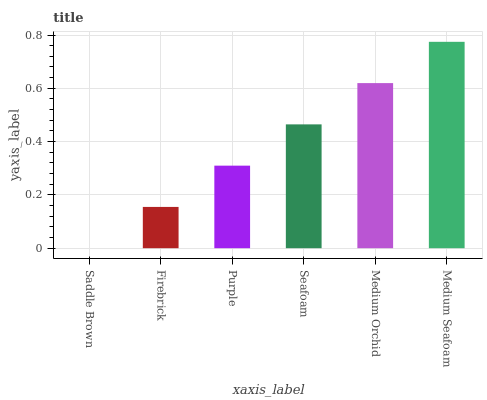Is Saddle Brown the minimum?
Answer yes or no. Yes. Is Medium Seafoam the maximum?
Answer yes or no. Yes. Is Firebrick the minimum?
Answer yes or no. No. Is Firebrick the maximum?
Answer yes or no. No. Is Firebrick greater than Saddle Brown?
Answer yes or no. Yes. Is Saddle Brown less than Firebrick?
Answer yes or no. Yes. Is Saddle Brown greater than Firebrick?
Answer yes or no. No. Is Firebrick less than Saddle Brown?
Answer yes or no. No. Is Seafoam the high median?
Answer yes or no. Yes. Is Purple the low median?
Answer yes or no. Yes. Is Medium Seafoam the high median?
Answer yes or no. No. Is Seafoam the low median?
Answer yes or no. No. 